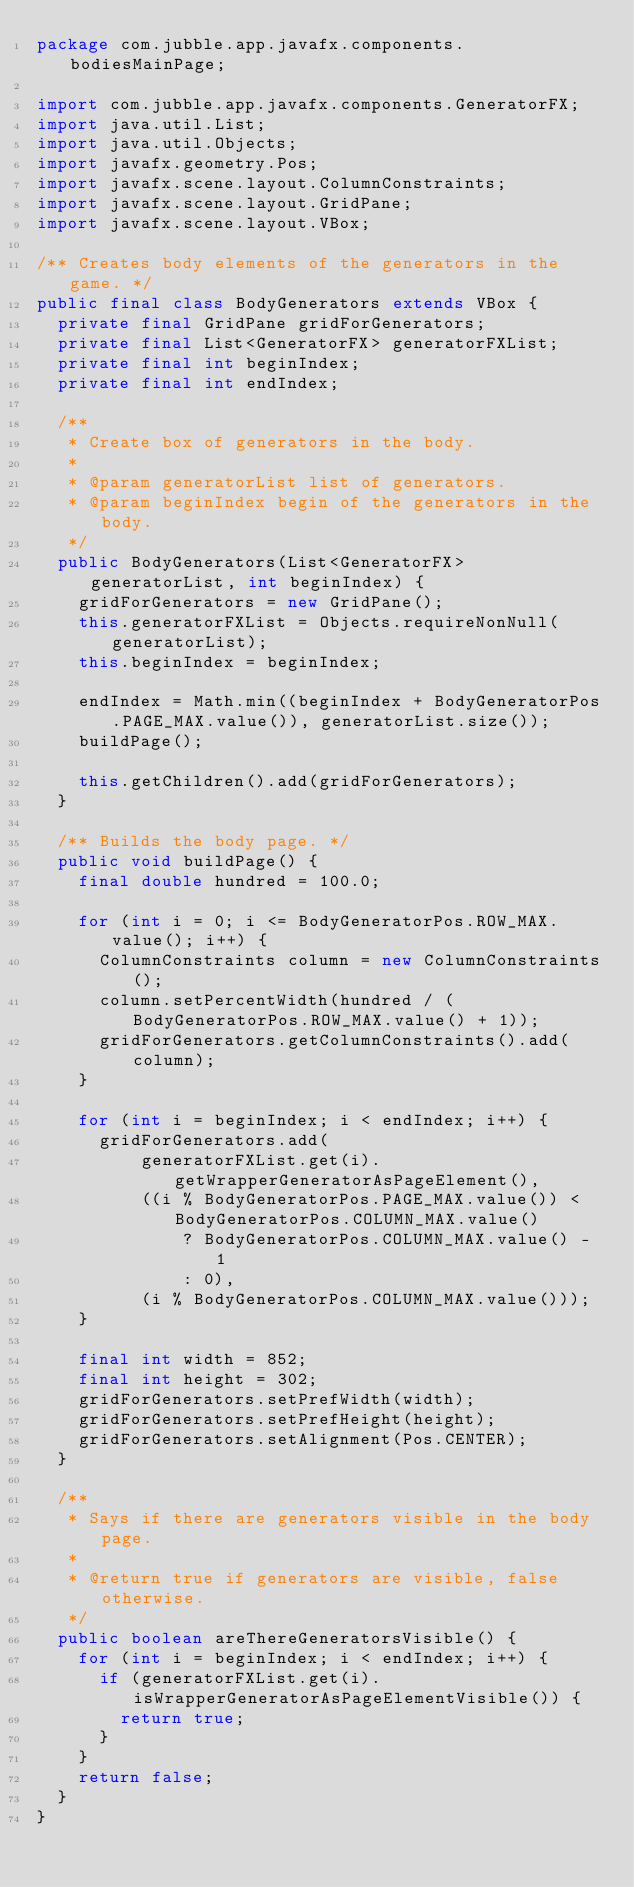<code> <loc_0><loc_0><loc_500><loc_500><_Java_>package com.jubble.app.javafx.components.bodiesMainPage;

import com.jubble.app.javafx.components.GeneratorFX;
import java.util.List;
import java.util.Objects;
import javafx.geometry.Pos;
import javafx.scene.layout.ColumnConstraints;
import javafx.scene.layout.GridPane;
import javafx.scene.layout.VBox;

/** Creates body elements of the generators in the game. */
public final class BodyGenerators extends VBox {
  private final GridPane gridForGenerators;
  private final List<GeneratorFX> generatorFXList;
  private final int beginIndex;
  private final int endIndex;

  /**
   * Create box of generators in the body.
   *
   * @param generatorList list of generators.
   * @param beginIndex begin of the generators in the body.
   */
  public BodyGenerators(List<GeneratorFX> generatorList, int beginIndex) {
    gridForGenerators = new GridPane();
    this.generatorFXList = Objects.requireNonNull(generatorList);
    this.beginIndex = beginIndex;

    endIndex = Math.min((beginIndex + BodyGeneratorPos.PAGE_MAX.value()), generatorList.size());
    buildPage();

    this.getChildren().add(gridForGenerators);
  }

  /** Builds the body page. */
  public void buildPage() {
    final double hundred = 100.0;

    for (int i = 0; i <= BodyGeneratorPos.ROW_MAX.value(); i++) {
      ColumnConstraints column = new ColumnConstraints();
      column.setPercentWidth(hundred / (BodyGeneratorPos.ROW_MAX.value() + 1));
      gridForGenerators.getColumnConstraints().add(column);
    }

    for (int i = beginIndex; i < endIndex; i++) {
      gridForGenerators.add(
          generatorFXList.get(i).getWrapperGeneratorAsPageElement(),
          ((i % BodyGeneratorPos.PAGE_MAX.value()) < BodyGeneratorPos.COLUMN_MAX.value()
              ? BodyGeneratorPos.COLUMN_MAX.value() - 1
              : 0),
          (i % BodyGeneratorPos.COLUMN_MAX.value()));
    }

    final int width = 852;
    final int height = 302;
    gridForGenerators.setPrefWidth(width);
    gridForGenerators.setPrefHeight(height);
    gridForGenerators.setAlignment(Pos.CENTER);
  }

  /**
   * Says if there are generators visible in the body page.
   *
   * @return true if generators are visible, false otherwise.
   */
  public boolean areThereGeneratorsVisible() {
    for (int i = beginIndex; i < endIndex; i++) {
      if (generatorFXList.get(i).isWrapperGeneratorAsPageElementVisible()) {
        return true;
      }
    }
    return false;
  }
}
</code> 